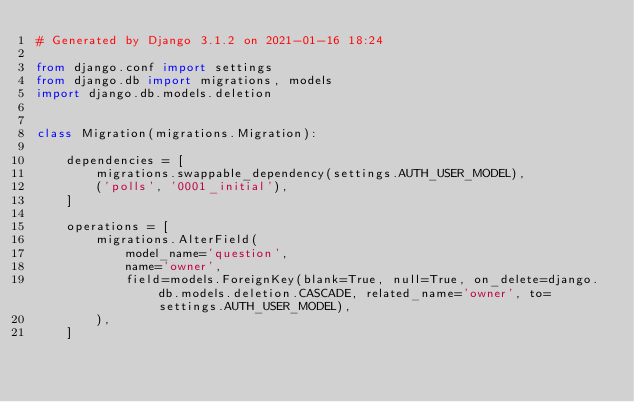Convert code to text. <code><loc_0><loc_0><loc_500><loc_500><_Python_># Generated by Django 3.1.2 on 2021-01-16 18:24

from django.conf import settings
from django.db import migrations, models
import django.db.models.deletion


class Migration(migrations.Migration):

    dependencies = [
        migrations.swappable_dependency(settings.AUTH_USER_MODEL),
        ('polls', '0001_initial'),
    ]

    operations = [
        migrations.AlterField(
            model_name='question',
            name='owner',
            field=models.ForeignKey(blank=True, null=True, on_delete=django.db.models.deletion.CASCADE, related_name='owner', to=settings.AUTH_USER_MODEL),
        ),
    ]
</code> 